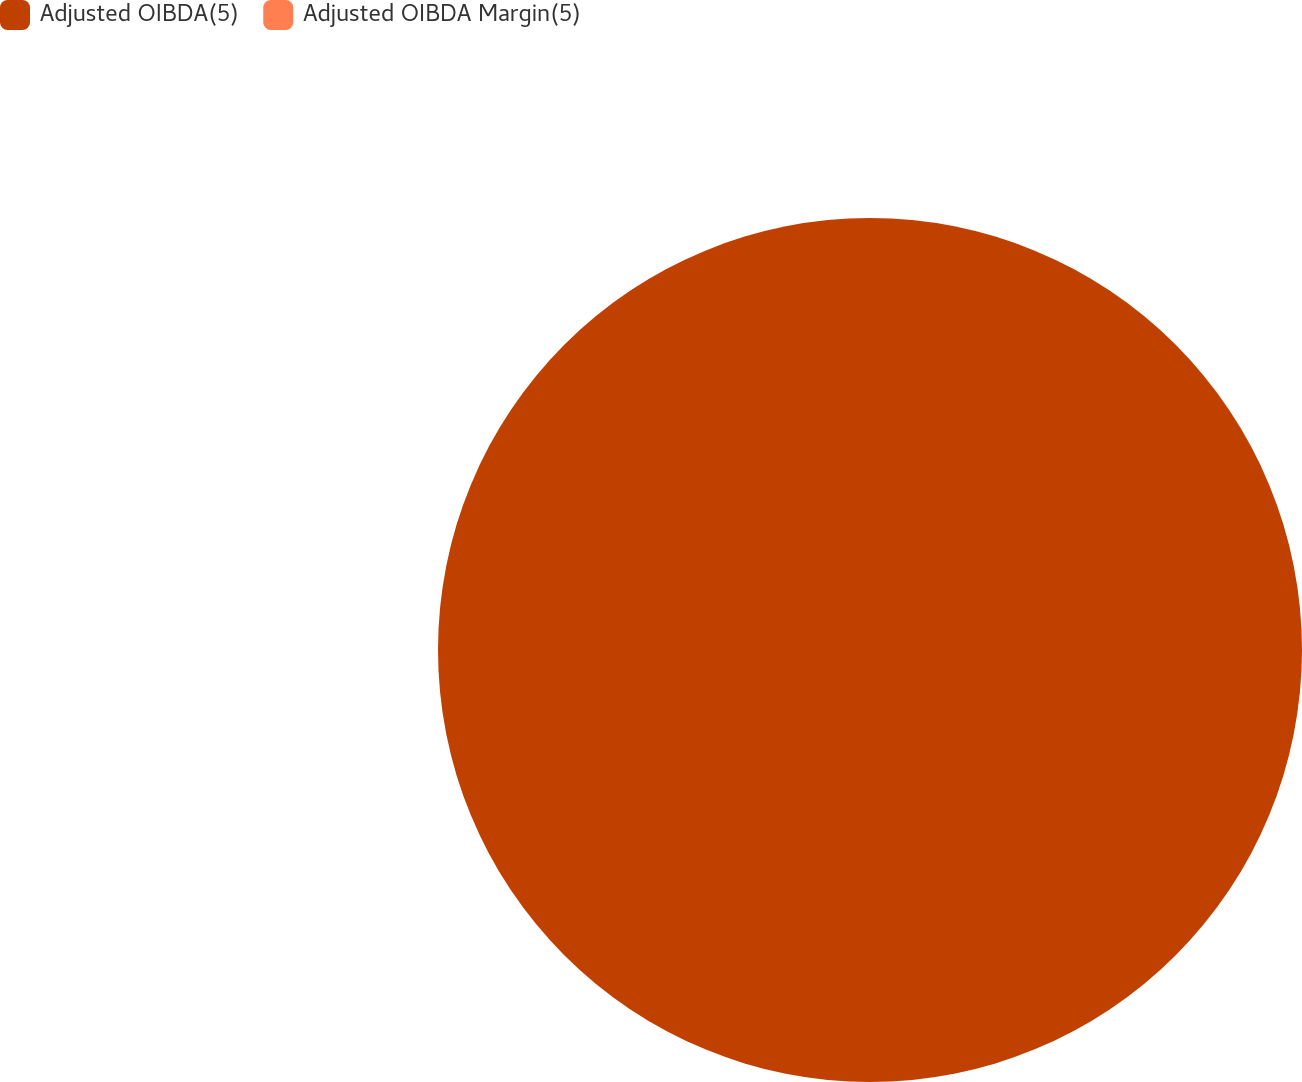Convert chart. <chart><loc_0><loc_0><loc_500><loc_500><pie_chart><fcel>Adjusted OIBDA(5)<fcel>Adjusted OIBDA Margin(5)<nl><fcel>100.0%<fcel>0.0%<nl></chart> 